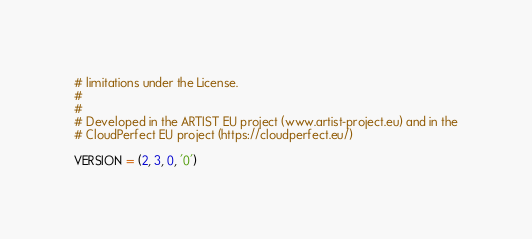<code> <loc_0><loc_0><loc_500><loc_500><_Python_># limitations under the License.
#
#
# Developed in the ARTIST EU project (www.artist-project.eu) and in the
# CloudPerfect EU project (https://cloudperfect.eu/)

VERSION = (2, 3, 0, '0')
</code> 